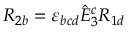<formula> <loc_0><loc_0><loc_500><loc_500>R _ { 2 b } = \varepsilon _ { b c d } \hat { E } _ { 3 } ^ { c } R _ { 1 d }</formula> 